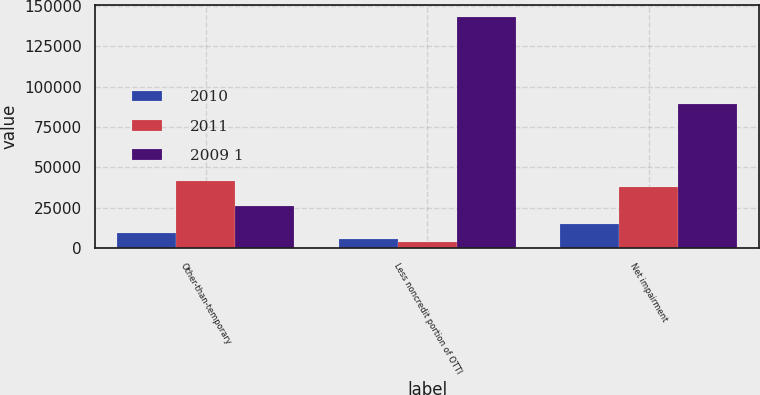Convert chart. <chart><loc_0><loc_0><loc_500><loc_500><stacked_bar_chart><ecel><fcel>Other-than-temporary<fcel>Less noncredit portion of OTTI<fcel>Net impairment<nl><fcel>2010<fcel>9190<fcel>5717<fcel>14907<nl><fcel>2011<fcel>41510<fcel>3840<fcel>37670<nl><fcel>2009 1<fcel>26288.5<fcel>143044<fcel>89095<nl></chart> 